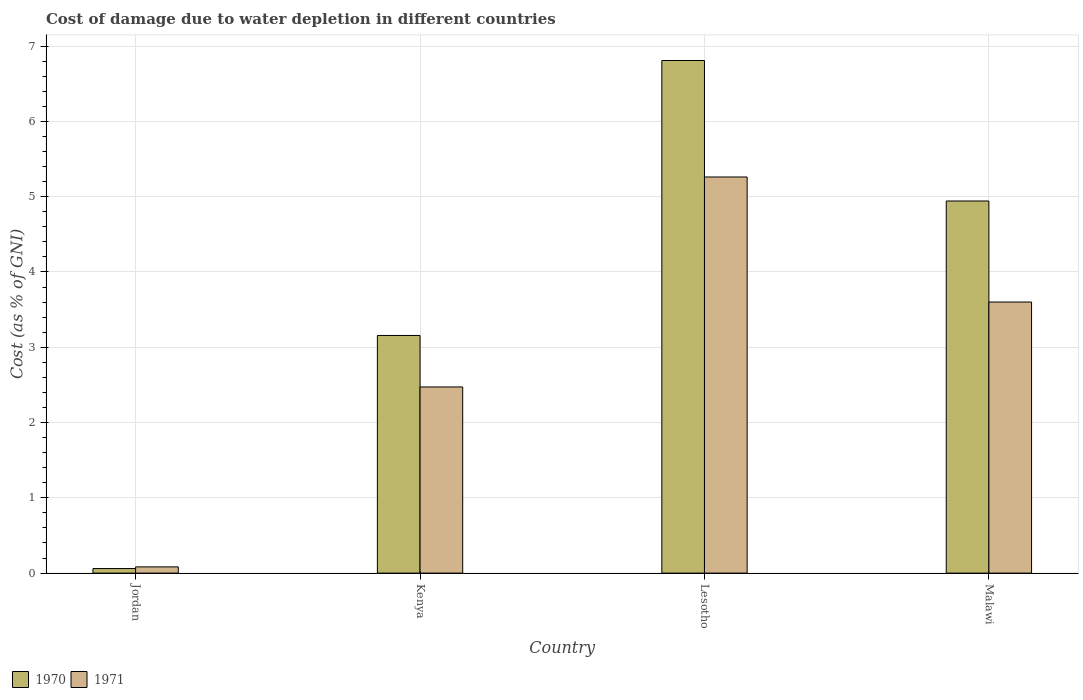How many different coloured bars are there?
Keep it short and to the point. 2. Are the number of bars on each tick of the X-axis equal?
Provide a succinct answer. Yes. What is the label of the 1st group of bars from the left?
Your response must be concise. Jordan. What is the cost of damage caused due to water depletion in 1970 in Malawi?
Offer a very short reply. 4.94. Across all countries, what is the maximum cost of damage caused due to water depletion in 1970?
Make the answer very short. 6.81. Across all countries, what is the minimum cost of damage caused due to water depletion in 1971?
Offer a terse response. 0.08. In which country was the cost of damage caused due to water depletion in 1970 maximum?
Offer a very short reply. Lesotho. In which country was the cost of damage caused due to water depletion in 1971 minimum?
Keep it short and to the point. Jordan. What is the total cost of damage caused due to water depletion in 1971 in the graph?
Offer a terse response. 11.42. What is the difference between the cost of damage caused due to water depletion in 1970 in Jordan and that in Kenya?
Keep it short and to the point. -3.1. What is the difference between the cost of damage caused due to water depletion in 1970 in Malawi and the cost of damage caused due to water depletion in 1971 in Lesotho?
Your response must be concise. -0.32. What is the average cost of damage caused due to water depletion in 1970 per country?
Give a very brief answer. 3.74. What is the difference between the cost of damage caused due to water depletion of/in 1970 and cost of damage caused due to water depletion of/in 1971 in Malawi?
Your response must be concise. 1.34. In how many countries, is the cost of damage caused due to water depletion in 1971 greater than 3 %?
Give a very brief answer. 2. What is the ratio of the cost of damage caused due to water depletion in 1971 in Jordan to that in Malawi?
Ensure brevity in your answer.  0.02. Is the cost of damage caused due to water depletion in 1970 in Kenya less than that in Malawi?
Give a very brief answer. Yes. Is the difference between the cost of damage caused due to water depletion in 1970 in Jordan and Malawi greater than the difference between the cost of damage caused due to water depletion in 1971 in Jordan and Malawi?
Provide a short and direct response. No. What is the difference between the highest and the second highest cost of damage caused due to water depletion in 1970?
Your response must be concise. -1.79. What is the difference between the highest and the lowest cost of damage caused due to water depletion in 1970?
Your answer should be very brief. 6.75. In how many countries, is the cost of damage caused due to water depletion in 1970 greater than the average cost of damage caused due to water depletion in 1970 taken over all countries?
Your answer should be very brief. 2. Is the sum of the cost of damage caused due to water depletion in 1970 in Kenya and Lesotho greater than the maximum cost of damage caused due to water depletion in 1971 across all countries?
Keep it short and to the point. Yes. What does the 2nd bar from the right in Lesotho represents?
Your answer should be very brief. 1970. How many bars are there?
Ensure brevity in your answer.  8. Are the values on the major ticks of Y-axis written in scientific E-notation?
Your answer should be very brief. No. Does the graph contain grids?
Offer a terse response. Yes. How many legend labels are there?
Your answer should be very brief. 2. What is the title of the graph?
Your answer should be compact. Cost of damage due to water depletion in different countries. What is the label or title of the Y-axis?
Ensure brevity in your answer.  Cost (as % of GNI). What is the Cost (as % of GNI) of 1970 in Jordan?
Offer a terse response. 0.06. What is the Cost (as % of GNI) in 1971 in Jordan?
Provide a short and direct response. 0.08. What is the Cost (as % of GNI) in 1970 in Kenya?
Ensure brevity in your answer.  3.16. What is the Cost (as % of GNI) of 1971 in Kenya?
Your response must be concise. 2.47. What is the Cost (as % of GNI) of 1970 in Lesotho?
Your answer should be very brief. 6.81. What is the Cost (as % of GNI) in 1971 in Lesotho?
Provide a succinct answer. 5.26. What is the Cost (as % of GNI) in 1970 in Malawi?
Your answer should be very brief. 4.94. What is the Cost (as % of GNI) of 1971 in Malawi?
Offer a terse response. 3.6. Across all countries, what is the maximum Cost (as % of GNI) in 1970?
Provide a short and direct response. 6.81. Across all countries, what is the maximum Cost (as % of GNI) of 1971?
Make the answer very short. 5.26. Across all countries, what is the minimum Cost (as % of GNI) in 1970?
Your response must be concise. 0.06. Across all countries, what is the minimum Cost (as % of GNI) of 1971?
Offer a very short reply. 0.08. What is the total Cost (as % of GNI) of 1970 in the graph?
Offer a terse response. 14.97. What is the total Cost (as % of GNI) in 1971 in the graph?
Make the answer very short. 11.42. What is the difference between the Cost (as % of GNI) in 1970 in Jordan and that in Kenya?
Ensure brevity in your answer.  -3.1. What is the difference between the Cost (as % of GNI) in 1971 in Jordan and that in Kenya?
Keep it short and to the point. -2.39. What is the difference between the Cost (as % of GNI) in 1970 in Jordan and that in Lesotho?
Make the answer very short. -6.75. What is the difference between the Cost (as % of GNI) of 1971 in Jordan and that in Lesotho?
Your answer should be compact. -5.18. What is the difference between the Cost (as % of GNI) of 1970 in Jordan and that in Malawi?
Offer a very short reply. -4.88. What is the difference between the Cost (as % of GNI) in 1971 in Jordan and that in Malawi?
Give a very brief answer. -3.52. What is the difference between the Cost (as % of GNI) in 1970 in Kenya and that in Lesotho?
Give a very brief answer. -3.65. What is the difference between the Cost (as % of GNI) of 1971 in Kenya and that in Lesotho?
Your response must be concise. -2.79. What is the difference between the Cost (as % of GNI) in 1970 in Kenya and that in Malawi?
Make the answer very short. -1.79. What is the difference between the Cost (as % of GNI) in 1971 in Kenya and that in Malawi?
Offer a terse response. -1.13. What is the difference between the Cost (as % of GNI) in 1970 in Lesotho and that in Malawi?
Make the answer very short. 1.87. What is the difference between the Cost (as % of GNI) in 1971 in Lesotho and that in Malawi?
Your response must be concise. 1.66. What is the difference between the Cost (as % of GNI) of 1970 in Jordan and the Cost (as % of GNI) of 1971 in Kenya?
Provide a succinct answer. -2.41. What is the difference between the Cost (as % of GNI) in 1970 in Jordan and the Cost (as % of GNI) in 1971 in Lesotho?
Provide a short and direct response. -5.2. What is the difference between the Cost (as % of GNI) in 1970 in Jordan and the Cost (as % of GNI) in 1971 in Malawi?
Offer a very short reply. -3.54. What is the difference between the Cost (as % of GNI) of 1970 in Kenya and the Cost (as % of GNI) of 1971 in Lesotho?
Provide a short and direct response. -2.1. What is the difference between the Cost (as % of GNI) in 1970 in Kenya and the Cost (as % of GNI) in 1971 in Malawi?
Your answer should be compact. -0.44. What is the difference between the Cost (as % of GNI) in 1970 in Lesotho and the Cost (as % of GNI) in 1971 in Malawi?
Offer a very short reply. 3.21. What is the average Cost (as % of GNI) in 1970 per country?
Make the answer very short. 3.74. What is the average Cost (as % of GNI) in 1971 per country?
Make the answer very short. 2.85. What is the difference between the Cost (as % of GNI) in 1970 and Cost (as % of GNI) in 1971 in Jordan?
Keep it short and to the point. -0.02. What is the difference between the Cost (as % of GNI) of 1970 and Cost (as % of GNI) of 1971 in Kenya?
Your answer should be compact. 0.68. What is the difference between the Cost (as % of GNI) of 1970 and Cost (as % of GNI) of 1971 in Lesotho?
Keep it short and to the point. 1.55. What is the difference between the Cost (as % of GNI) in 1970 and Cost (as % of GNI) in 1971 in Malawi?
Provide a succinct answer. 1.34. What is the ratio of the Cost (as % of GNI) in 1970 in Jordan to that in Kenya?
Make the answer very short. 0.02. What is the ratio of the Cost (as % of GNI) in 1970 in Jordan to that in Lesotho?
Offer a very short reply. 0.01. What is the ratio of the Cost (as % of GNI) of 1971 in Jordan to that in Lesotho?
Make the answer very short. 0.02. What is the ratio of the Cost (as % of GNI) of 1970 in Jordan to that in Malawi?
Your answer should be compact. 0.01. What is the ratio of the Cost (as % of GNI) of 1971 in Jordan to that in Malawi?
Your answer should be compact. 0.02. What is the ratio of the Cost (as % of GNI) of 1970 in Kenya to that in Lesotho?
Ensure brevity in your answer.  0.46. What is the ratio of the Cost (as % of GNI) of 1971 in Kenya to that in Lesotho?
Make the answer very short. 0.47. What is the ratio of the Cost (as % of GNI) of 1970 in Kenya to that in Malawi?
Offer a very short reply. 0.64. What is the ratio of the Cost (as % of GNI) in 1971 in Kenya to that in Malawi?
Ensure brevity in your answer.  0.69. What is the ratio of the Cost (as % of GNI) in 1970 in Lesotho to that in Malawi?
Your answer should be compact. 1.38. What is the ratio of the Cost (as % of GNI) of 1971 in Lesotho to that in Malawi?
Keep it short and to the point. 1.46. What is the difference between the highest and the second highest Cost (as % of GNI) in 1970?
Provide a succinct answer. 1.87. What is the difference between the highest and the second highest Cost (as % of GNI) in 1971?
Offer a very short reply. 1.66. What is the difference between the highest and the lowest Cost (as % of GNI) in 1970?
Ensure brevity in your answer.  6.75. What is the difference between the highest and the lowest Cost (as % of GNI) of 1971?
Make the answer very short. 5.18. 